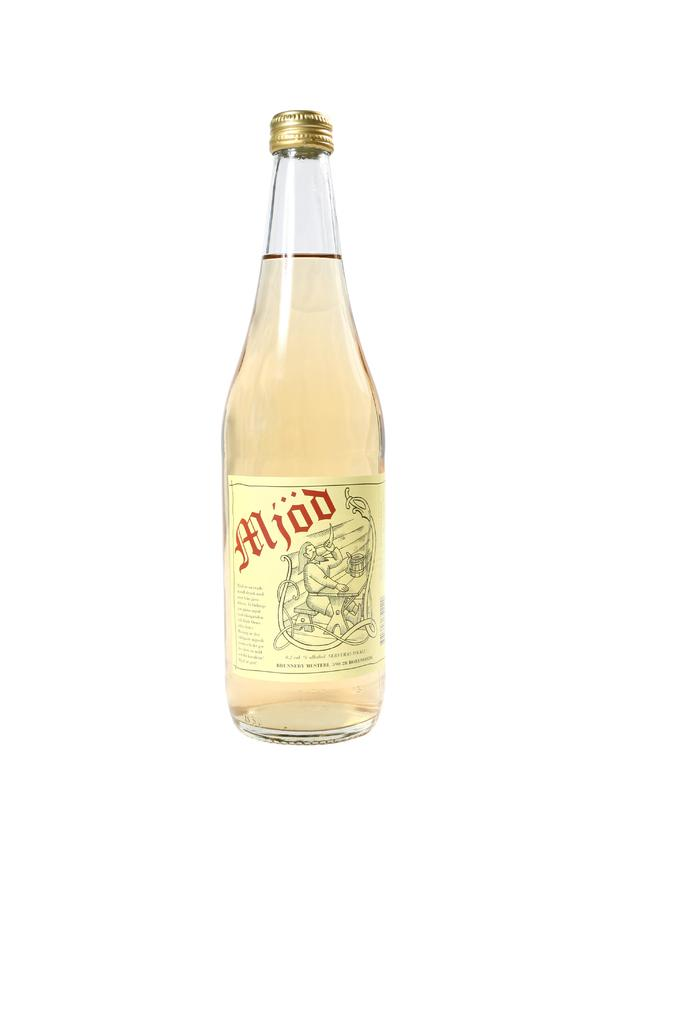What object can be seen in the image? There is a bottle in the image. What is on the bottle? The bottle has a label on it. Is the bottle closed or open? There is a cap on the bottle. What type of marble is used to decorate the bottle in the image? There is no marble present in the image; it features a bottle with a label and a cap. What system is responsible for the production of the bottle in the image? The image does not provide information about the production process or system for the bottle. 